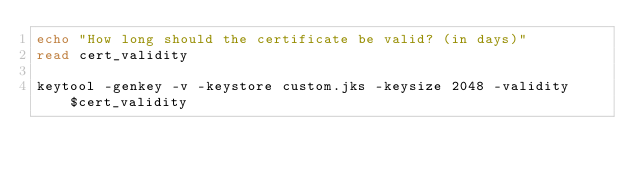Convert code to text. <code><loc_0><loc_0><loc_500><loc_500><_Bash_>echo "How long should the certificate be valid? (in days)"
read cert_validity

keytool -genkey -v -keystore custom.jks -keysize 2048 -validity $cert_validity</code> 